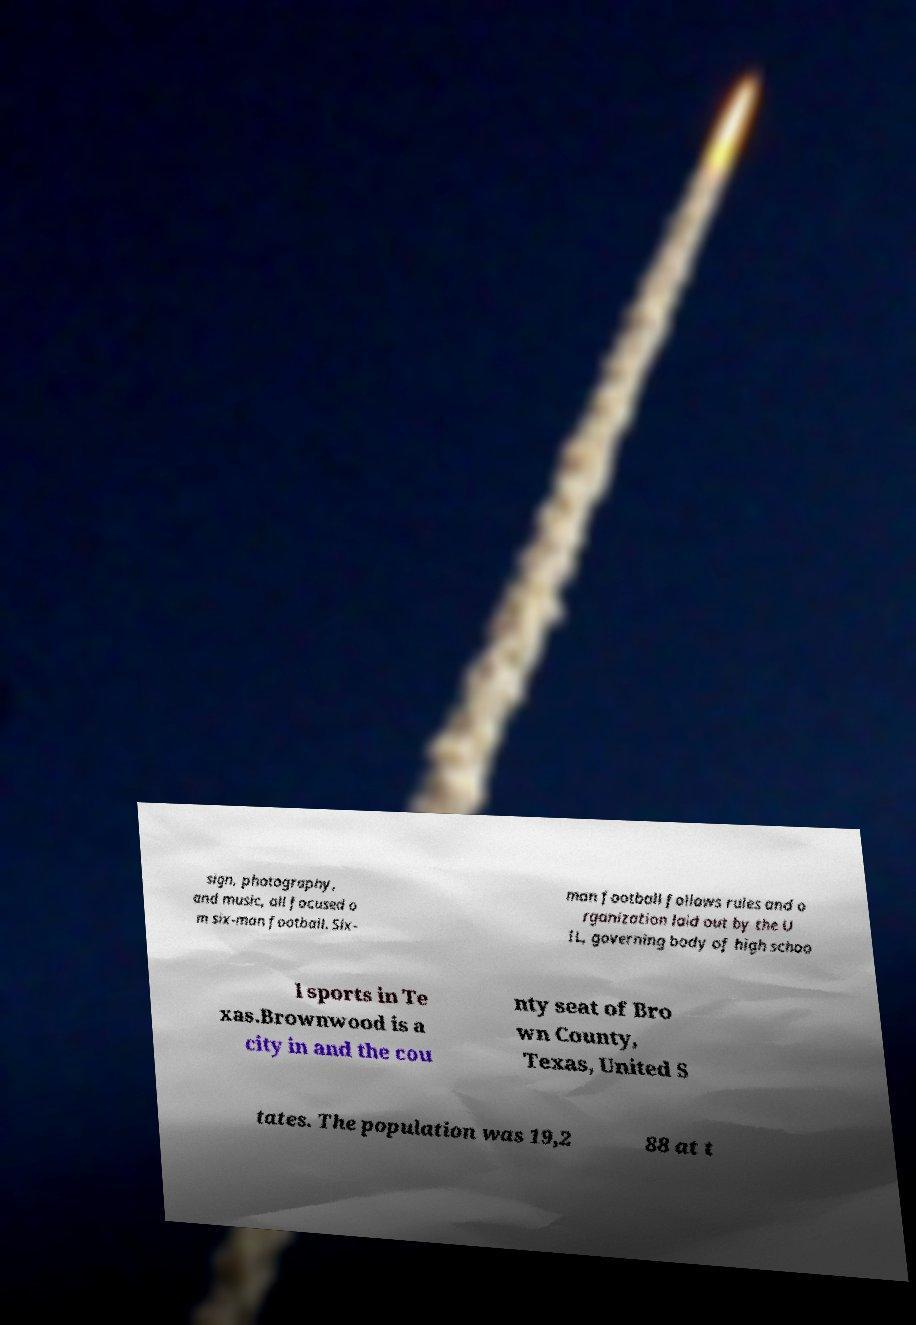Could you assist in decoding the text presented in this image and type it out clearly? sign, photography, and music, all focused o m six-man football. Six- man football follows rules and o rganization laid out by the U IL, governing body of high schoo l sports in Te xas.Brownwood is a city in and the cou nty seat of Bro wn County, Texas, United S tates. The population was 19,2 88 at t 